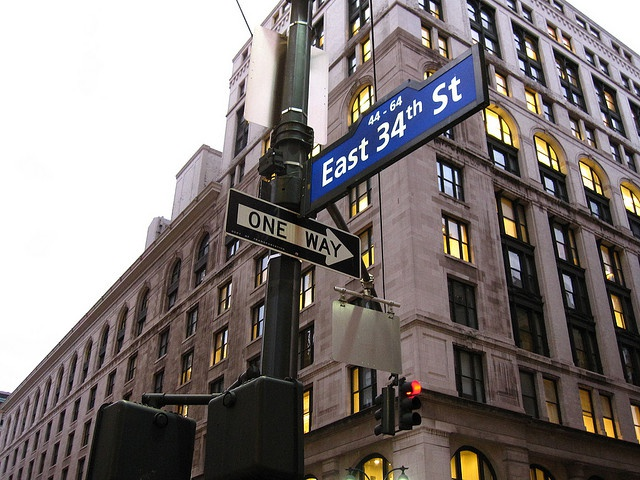Describe the objects in this image and their specific colors. I can see traffic light in white, black, and gray tones, traffic light in white, black, and gray tones, traffic light in white, black, and gray tones, and traffic light in white, black, gray, maroon, and red tones in this image. 